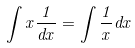Convert formula to latex. <formula><loc_0><loc_0><loc_500><loc_500>\int x \frac { 1 } { d x } = \int \frac { 1 } { x } d x</formula> 